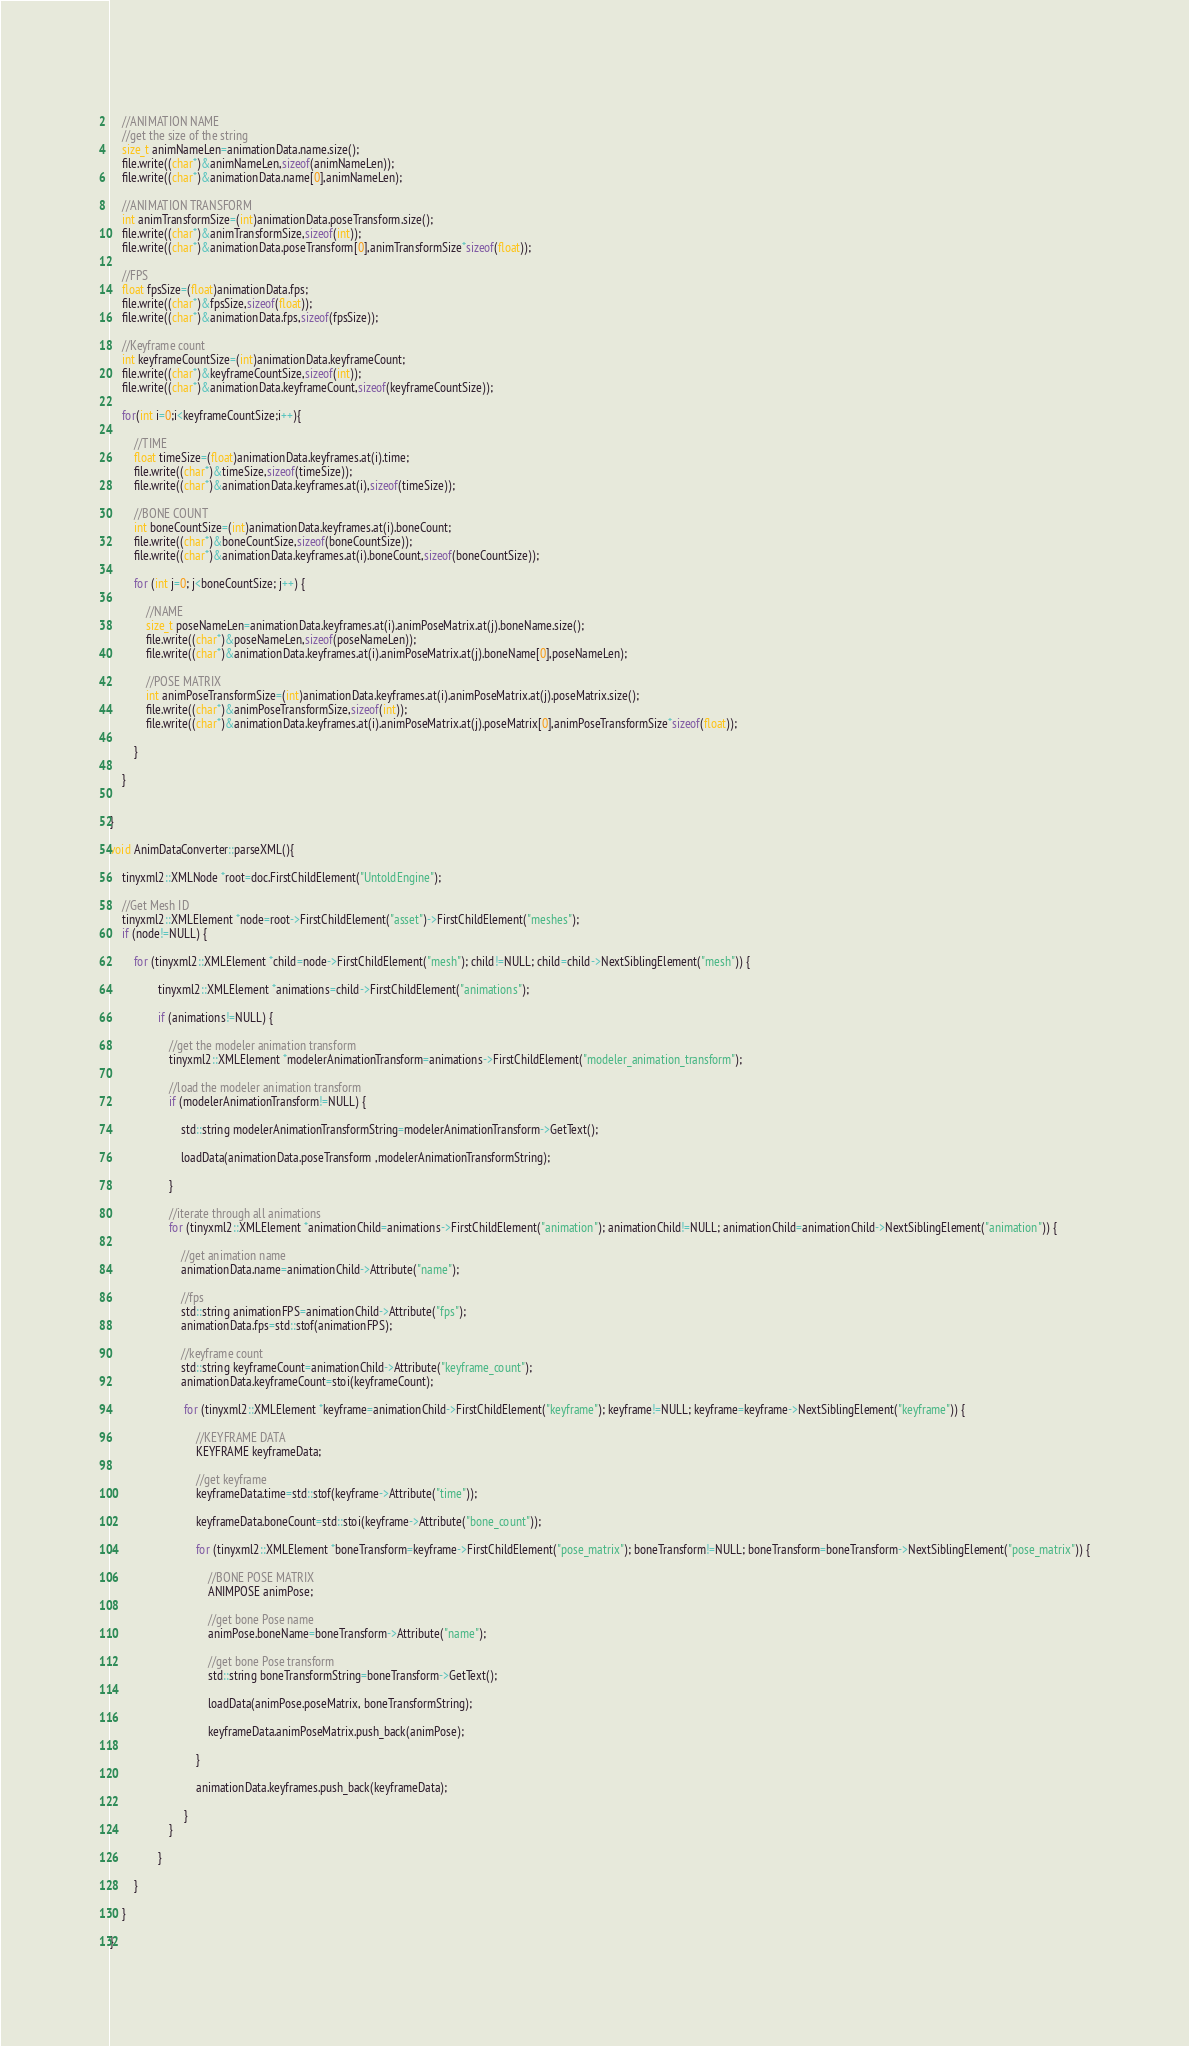<code> <loc_0><loc_0><loc_500><loc_500><_ObjectiveC_>    
    //ANIMATION NAME
    //get the size of the string
    size_t animNameLen=animationData.name.size();
    file.write((char*)&animNameLen,sizeof(animNameLen));
    file.write((char*)&animationData.name[0],animNameLen);
    
    //ANIMATION TRANSFORM
    int animTransformSize=(int)animationData.poseTransform.size();
    file.write((char*)&animTransformSize,sizeof(int));
    file.write((char*)&animationData.poseTransform[0],animTransformSize*sizeof(float));
        
    //FPS
    float fpsSize=(float)animationData.fps;
    file.write((char*)&fpsSize,sizeof(float));
    file.write((char*)&animationData.fps,sizeof(fpsSize));
    
    //Keyframe count
    int keyframeCountSize=(int)animationData.keyframeCount;
    file.write((char*)&keyframeCountSize,sizeof(int));
    file.write((char*)&animationData.keyframeCount,sizeof(keyframeCountSize));
    
    for(int i=0;i<keyframeCountSize;i++){
        
        //TIME
        float timeSize=(float)animationData.keyframes.at(i).time;
        file.write((char*)&timeSize,sizeof(timeSize));
        file.write((char*)&animationData.keyframes.at(i),sizeof(timeSize));
        
        //BONE COUNT
        int boneCountSize=(int)animationData.keyframes.at(i).boneCount;
        file.write((char*)&boneCountSize,sizeof(boneCountSize));
        file.write((char*)&animationData.keyframes.at(i).boneCount,sizeof(boneCountSize));
        
        for (int j=0; j<boneCountSize; j++) {
            
            //NAME
            size_t poseNameLen=animationData.keyframes.at(i).animPoseMatrix.at(j).boneName.size();
            file.write((char*)&poseNameLen,sizeof(poseNameLen));
            file.write((char*)&animationData.keyframes.at(i).animPoseMatrix.at(j).boneName[0],poseNameLen);
            
            //POSE MATRIX
            int animPoseTransformSize=(int)animationData.keyframes.at(i).animPoseMatrix.at(j).poseMatrix.size();
            file.write((char*)&animPoseTransformSize,sizeof(int));
            file.write((char*)&animationData.keyframes.at(i).animPoseMatrix.at(j).poseMatrix[0],animPoseTransformSize*sizeof(float));
            
        }
        
    }
    
    
}

void AnimDataConverter::parseXML(){
    
    tinyxml2::XMLNode *root=doc.FirstChildElement("UntoldEngine");
    
    //Get Mesh ID
    tinyxml2::XMLElement *node=root->FirstChildElement("asset")->FirstChildElement("meshes");
    if (node!=NULL) {
        
        for (tinyxml2::XMLElement *child=node->FirstChildElement("mesh"); child!=NULL; child=child->NextSiblingElement("mesh")) {
            
                tinyxml2::XMLElement *animations=child->FirstChildElement("animations");
                
                if (animations!=NULL) {
                    
                    //get the modeler animation transform
                    tinyxml2::XMLElement *modelerAnimationTransform=animations->FirstChildElement("modeler_animation_transform");
                    
                    //load the modeler animation transform
                    if (modelerAnimationTransform!=NULL) {
                        
                        std::string modelerAnimationTransformString=modelerAnimationTransform->GetText();
                        
                        loadData(animationData.poseTransform ,modelerAnimationTransformString);
                        
                    }
                    
                    //iterate through all animations
                    for (tinyxml2::XMLElement *animationChild=animations->FirstChildElement("animation"); animationChild!=NULL; animationChild=animationChild->NextSiblingElement("animation")) {
                        
                        //get animation name
                        animationData.name=animationChild->Attribute("name");
                        
                        //fps
                        std::string animationFPS=animationChild->Attribute("fps");
                        animationData.fps=std::stof(animationFPS);
                        
                        //keyframe count
                        std::string keyframeCount=animationChild->Attribute("keyframe_count");
                        animationData.keyframeCount=stoi(keyframeCount);
                        
                         for (tinyxml2::XMLElement *keyframe=animationChild->FirstChildElement("keyframe"); keyframe!=NULL; keyframe=keyframe->NextSiblingElement("keyframe")) {
                          
                             //KEYFRAME DATA
                             KEYFRAME keyframeData;
                             
                             //get keyframe
                             keyframeData.time=std::stof(keyframe->Attribute("time"));
                             
                             keyframeData.boneCount=std::stoi(keyframe->Attribute("bone_count"));
                             
                             for (tinyxml2::XMLElement *boneTransform=keyframe->FirstChildElement("pose_matrix"); boneTransform!=NULL; boneTransform=boneTransform->NextSiblingElement("pose_matrix")) {
                                 
                                 //BONE POSE MATRIX
                                 ANIMPOSE animPose;
                                 
                                 //get bone Pose name
                                 animPose.boneName=boneTransform->Attribute("name");
                                 
                                 //get bone Pose transform
                                 std::string boneTransformString=boneTransform->GetText();
                                 
                                 loadData(animPose.poseMatrix, boneTransformString);
                                 
                                 keyframeData.animPoseMatrix.push_back(animPose);
                                 
                             }
                             
                             animationData.keyframes.push_back(keyframeData);
                             
                         }
                    }
                    
                }
            
        }
        
    }
    
}
</code> 